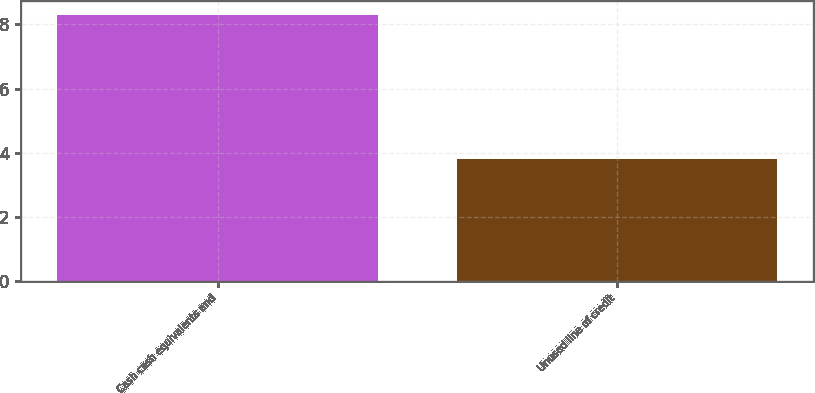Convert chart. <chart><loc_0><loc_0><loc_500><loc_500><bar_chart><fcel>Cash cash equivalents and<fcel>Unused line of credit<nl><fcel>8.3<fcel>3.8<nl></chart> 